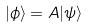<formula> <loc_0><loc_0><loc_500><loc_500>| \phi \rangle = A | \psi \rangle</formula> 